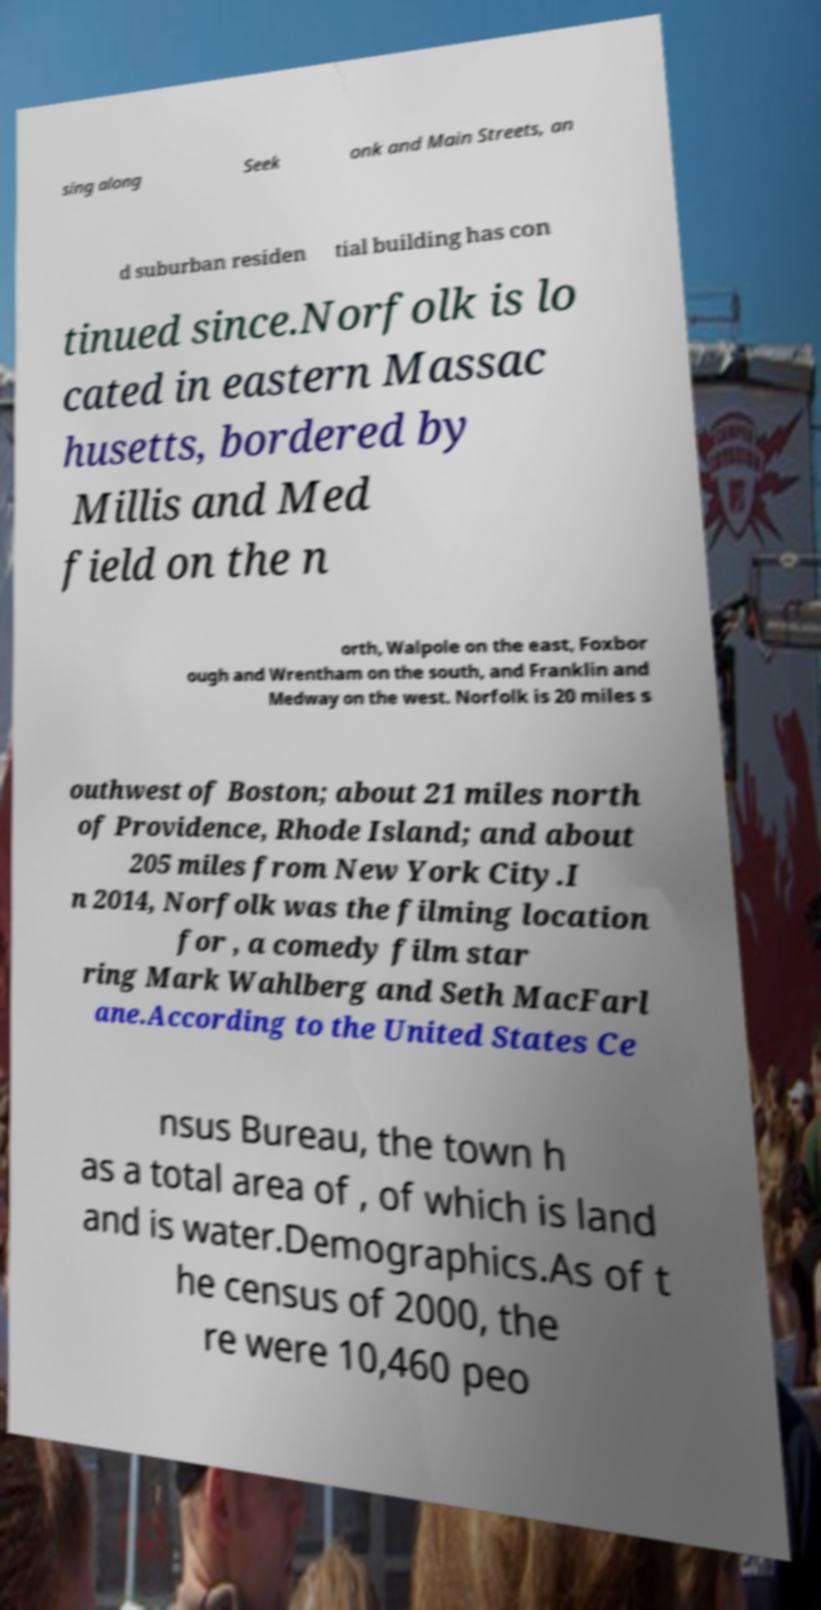Please identify and transcribe the text found in this image. sing along Seek onk and Main Streets, an d suburban residen tial building has con tinued since.Norfolk is lo cated in eastern Massac husetts, bordered by Millis and Med field on the n orth, Walpole on the east, Foxbor ough and Wrentham on the south, and Franklin and Medway on the west. Norfolk is 20 miles s outhwest of Boston; about 21 miles north of Providence, Rhode Island; and about 205 miles from New York City.I n 2014, Norfolk was the filming location for , a comedy film star ring Mark Wahlberg and Seth MacFarl ane.According to the United States Ce nsus Bureau, the town h as a total area of , of which is land and is water.Demographics.As of t he census of 2000, the re were 10,460 peo 